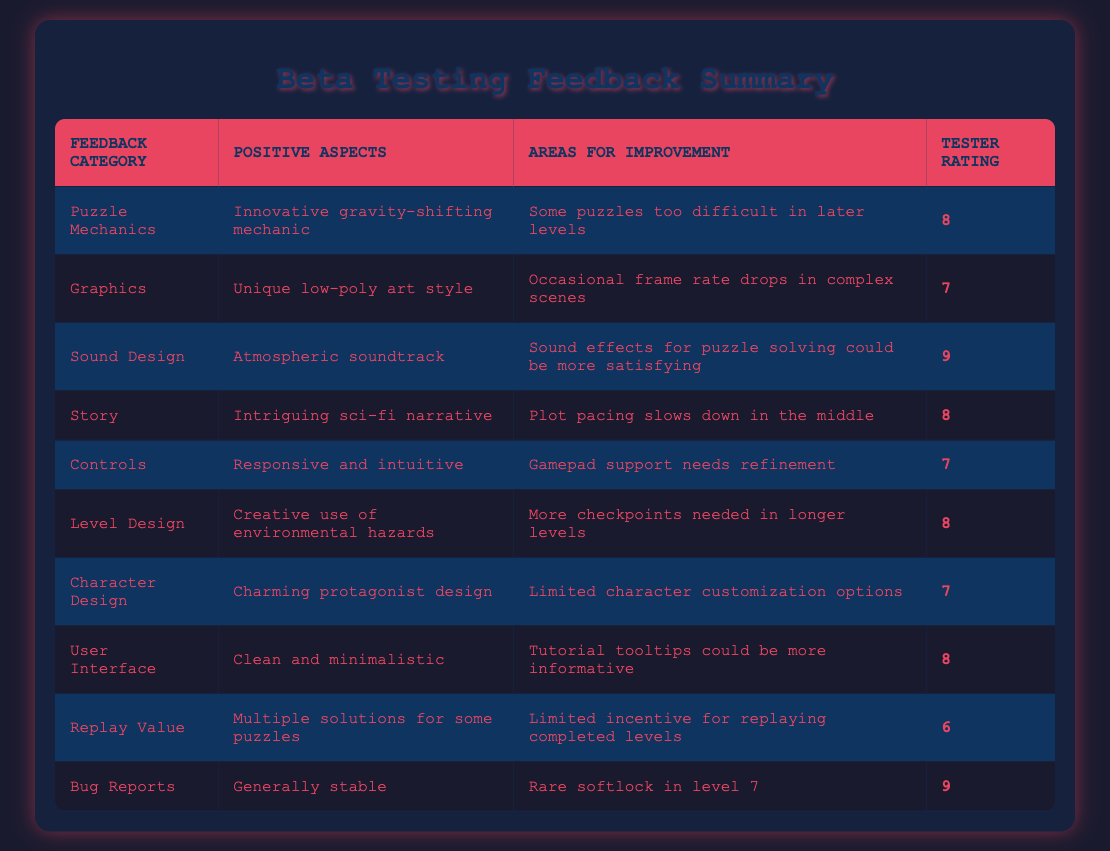What is the positive aspect of the Puzzle Mechanics category? The table indicates that the positive aspect for Puzzle Mechanics is "Innovative gravity-shifting mechanic," which is specifically stated in that row under the Positive Aspects column.
Answer: Innovative gravity-shifting mechanic Which feedback category received the highest tester rating? By examining the Tester Rating column, I notice that the Sound Design and Bug Reports categories both have the highest rating of 9. Comparing these two, Sound Design is listed first in the sequence.
Answer: Sound Design What is the average tester rating across all categories? To calculate the average tester rating, I sum all the ratings: 8 + 7 + 9 + 8 + 7 + 8 + 7 + 8 + 6 + 9 = 78. There are 10 categories, so I divide the total by 10: 78/10 = 7.8.
Answer: 7.8 Is there a feedback category with a rating below 7? Reviewing the Tester Rating column, I find that Replay Value has the lowest rating of 6, which confirms there is at least one category with a rating below 7.
Answer: Yes Which feedback categories mention issues related to duration or pacing? The Story category mentions "Plot pacing slows down in the middle," and the Level Design category suggests, "More checkpoints needed in longer levels." These issues relate to duration and pacing in gameplay.
Answer: Story, Level Design What is the positive aspect listed for Graphics? The Graphics category states a positive aspect of "Unique low-poly art style," clearly indicated in the table under the Positive Aspects column for that category.
Answer: Unique low-poly art style How many categories received a rating of 8 or higher? I analyze the Tester Rating column and find the categories with a rating of 8 or higher: Puzzle Mechanics, Sound Design, Story, Level Design, User Interface, and Bug Reports. This totals to 6 categories.
Answer: 6 Do the Controls and Character Design categories share any similar areas for improvement? Both categories mention areas for improvement related to support or options: Controls state "Gamepad support needs refinement" while Character Design indicates "Limited character customization options." They focus on enhancing player experience but in different ways.
Answer: No 